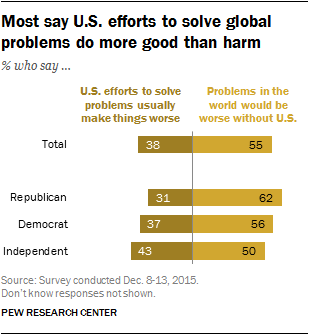Specify some key components in this picture. According to a recent survey, 50% of independent voters believe that problems in the world would be worse without the United States. The average of all the Total bars is equal to the average of all the Democrat bars. 